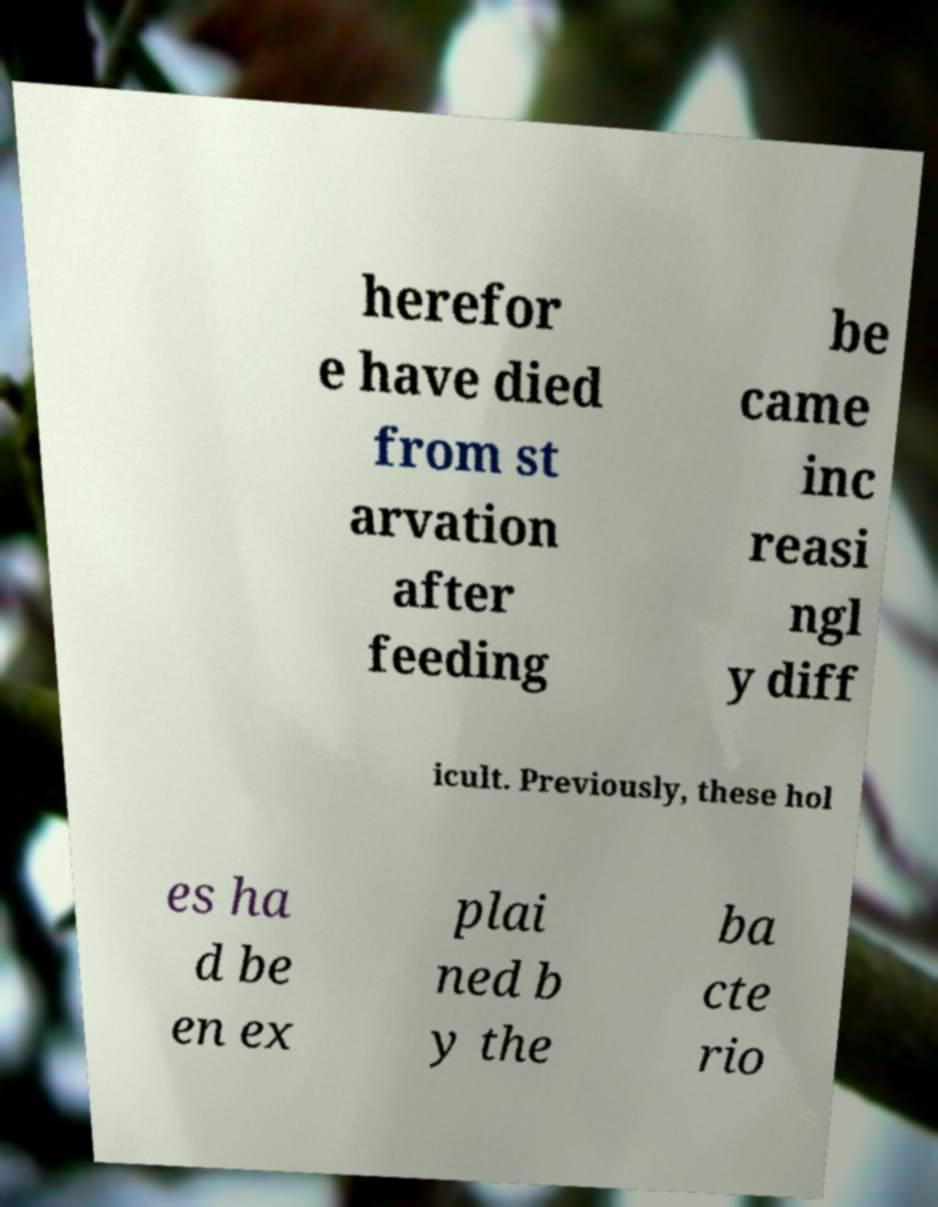Could you extract and type out the text from this image? herefor e have died from st arvation after feeding be came inc reasi ngl y diff icult. Previously, these hol es ha d be en ex plai ned b y the ba cte rio 